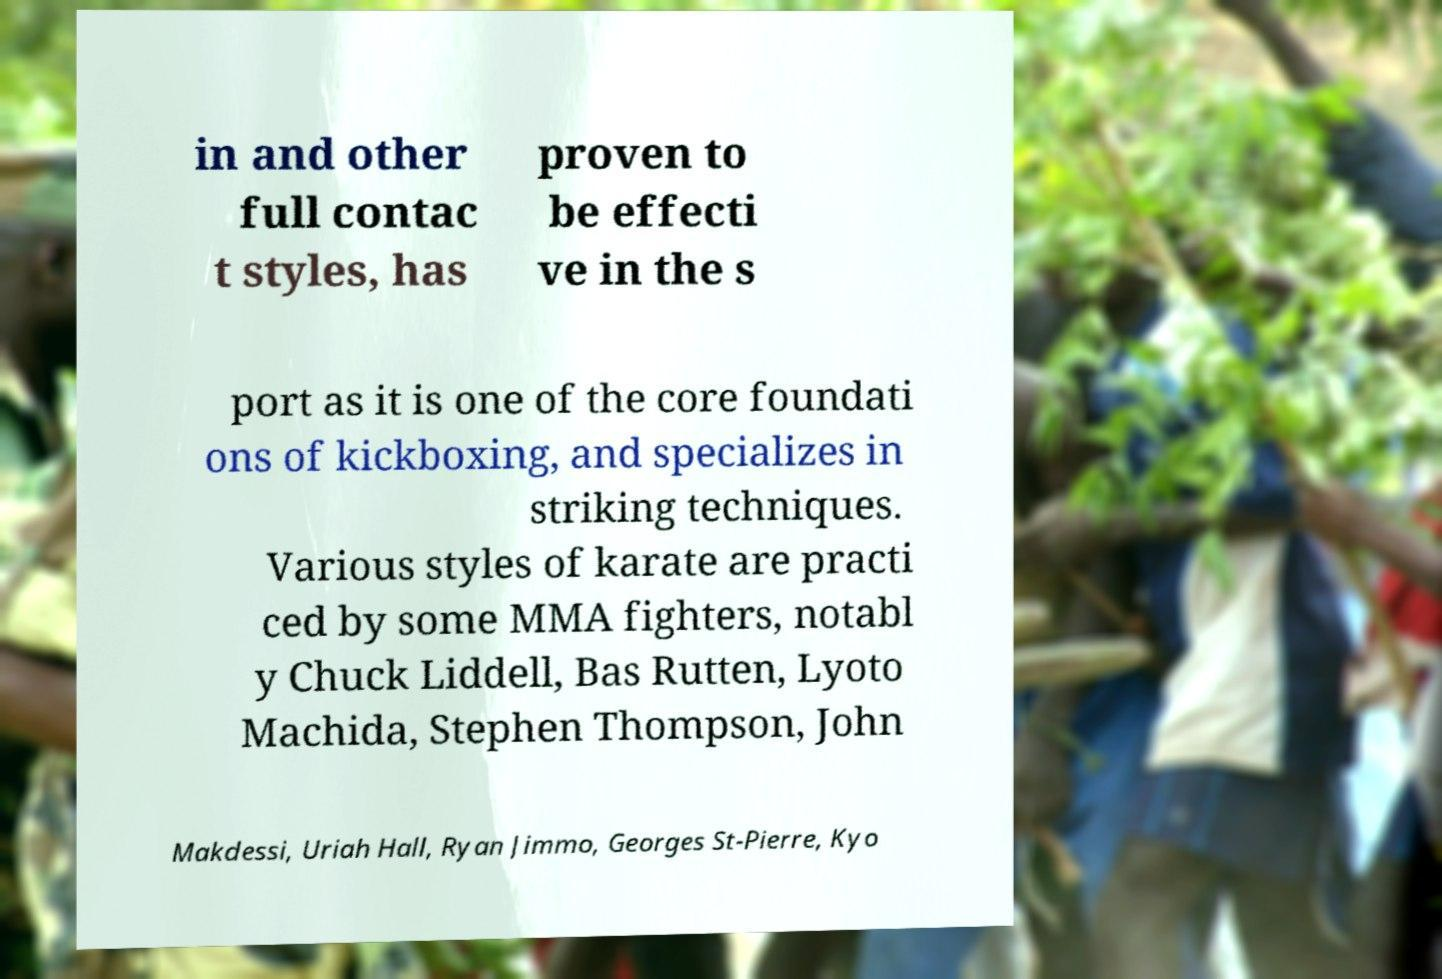Please read and relay the text visible in this image. What does it say? in and other full contac t styles, has proven to be effecti ve in the s port as it is one of the core foundati ons of kickboxing, and specializes in striking techniques. Various styles of karate are practi ced by some MMA fighters, notabl y Chuck Liddell, Bas Rutten, Lyoto Machida, Stephen Thompson, John Makdessi, Uriah Hall, Ryan Jimmo, Georges St-Pierre, Kyo 